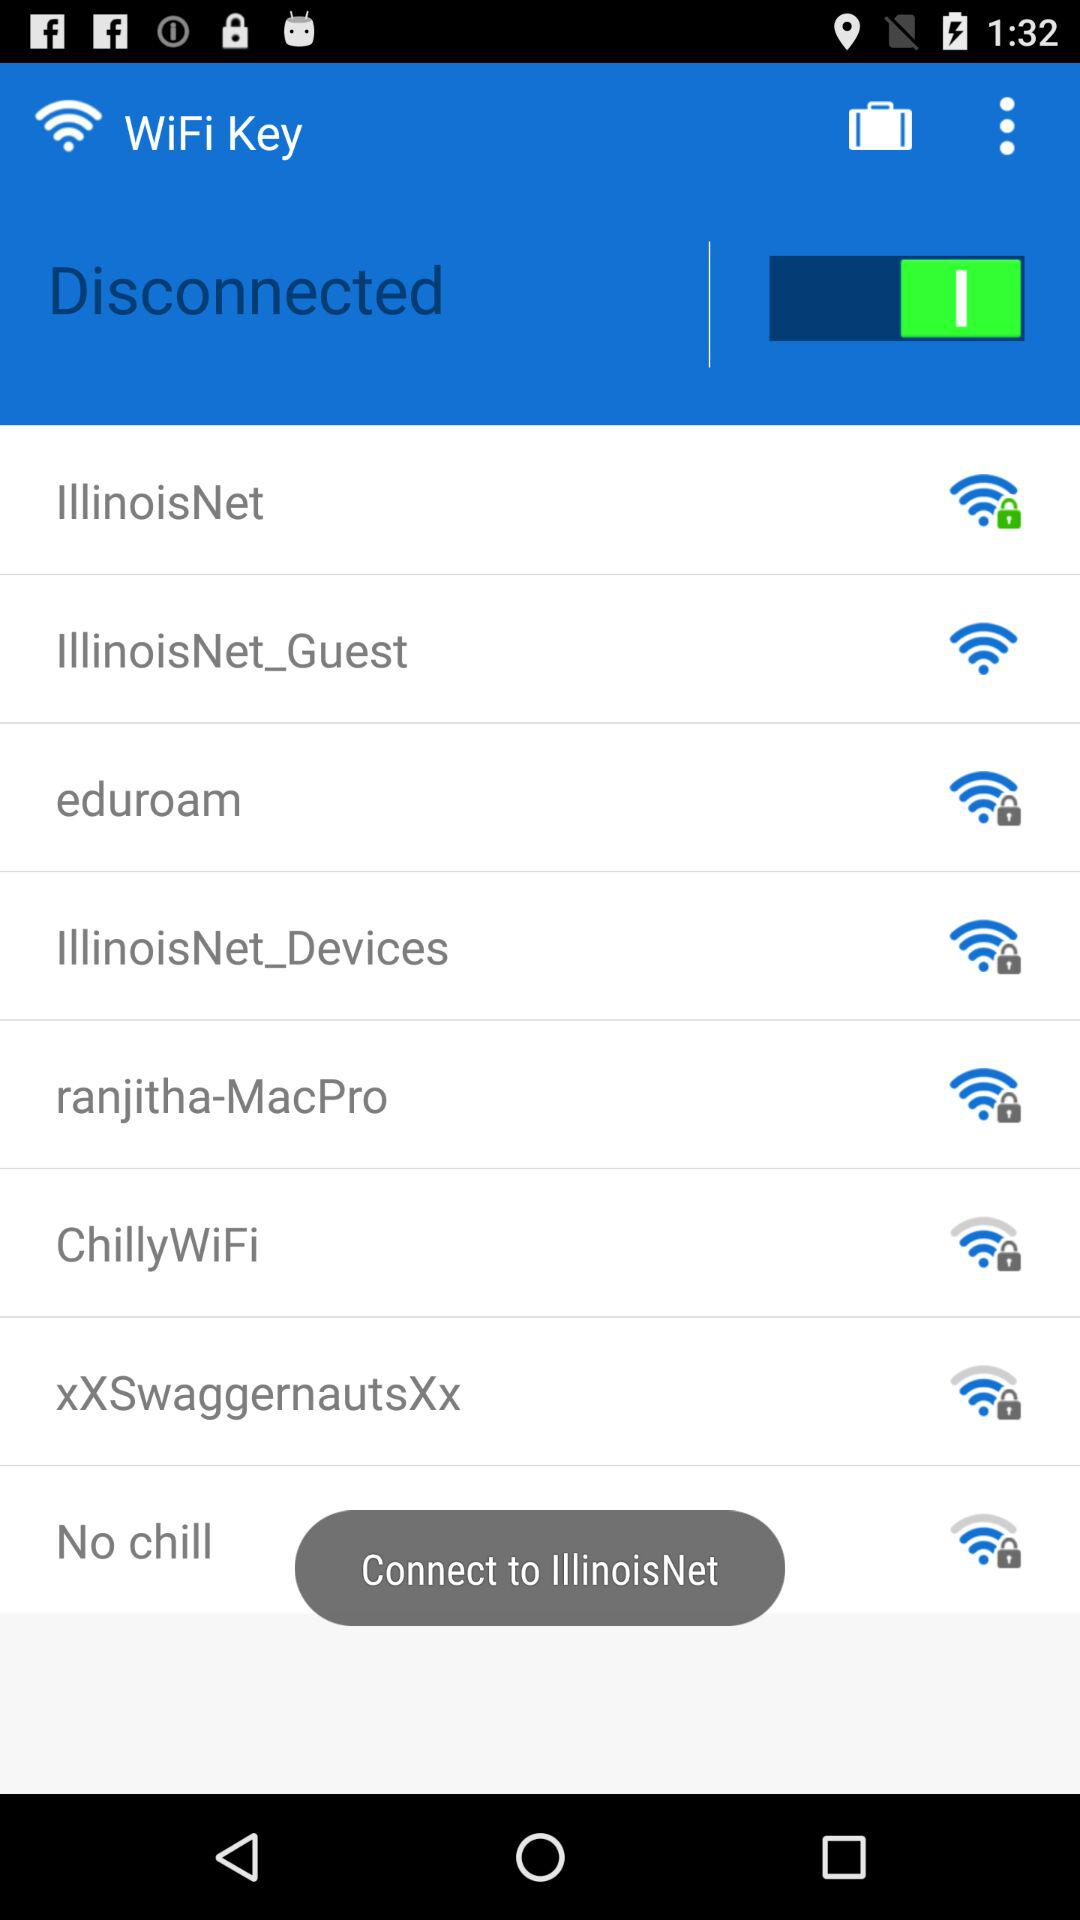Which WiFi network option is not secured? The unsecure WiFi network is "IllinoisNet_Guest". 